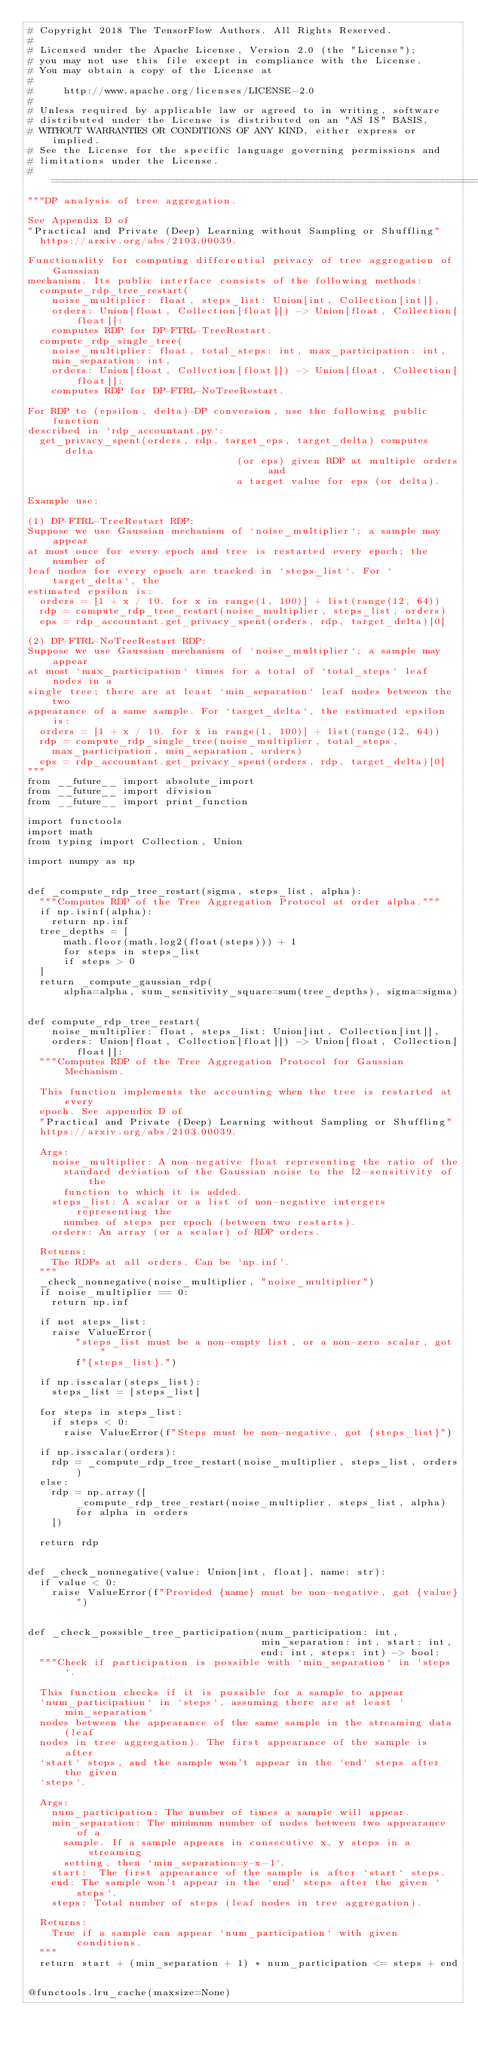<code> <loc_0><loc_0><loc_500><loc_500><_Python_># Copyright 2018 The TensorFlow Authors. All Rights Reserved.
#
# Licensed under the Apache License, Version 2.0 (the "License");
# you may not use this file except in compliance with the License.
# You may obtain a copy of the License at
#
#     http://www.apache.org/licenses/LICENSE-2.0
#
# Unless required by applicable law or agreed to in writing, software
# distributed under the License is distributed on an "AS IS" BASIS,
# WITHOUT WARRANTIES OR CONDITIONS OF ANY KIND, either express or implied.
# See the License for the specific language governing permissions and
# limitations under the License.
# ==============================================================================
"""DP analysis of tree aggregation.

See Appendix D of
"Practical and Private (Deep) Learning without Sampling or Shuffling"
  https://arxiv.org/abs/2103.00039.

Functionality for computing differential privacy of tree aggregation of Gaussian
mechanism. Its public interface consists of the following methods:
  compute_rdp_tree_restart(
    noise_multiplier: float, steps_list: Union[int, Collection[int]],
    orders: Union[float, Collection[float]]) -> Union[float, Collection[float]]:
    computes RDP for DP-FTRL-TreeRestart.
  compute_rdp_single_tree(
    noise_multiplier: float, total_steps: int, max_participation: int,
    min_separation: int,
    orders: Union[float, Collection[float]]) -> Union[float, Collection[float]]:
    computes RDP for DP-FTRL-NoTreeRestart.

For RDP to (epsilon, delta)-DP conversion, use the following public function
described in `rdp_accountant.py`:
  get_privacy_spent(orders, rdp, target_eps, target_delta) computes delta
                                   (or eps) given RDP at multiple orders and
                                   a target value for eps (or delta).

Example use:

(1) DP-FTRL-TreeRestart RDP:
Suppose we use Gaussian mechanism of `noise_multiplier`; a sample may appear
at most once for every epoch and tree is restarted every epoch; the number of
leaf nodes for every epoch are tracked in `steps_list`. For `target_delta`, the
estimated epsilon is:
  orders = [1 + x / 10. for x in range(1, 100)] + list(range(12, 64))
  rdp = compute_rdp_tree_restart(noise_multiplier, steps_list, orders)
  eps = rdp_accountant.get_privacy_spent(orders, rdp, target_delta)[0]

(2) DP-FTRL-NoTreeRestart RDP:
Suppose we use Gaussian mechanism of `noise_multiplier`; a sample may appear
at most `max_participation` times for a total of `total_steps` leaf nodes in a
single tree; there are at least `min_separation` leaf nodes between the two
appearance of a same sample. For `target_delta`, the estimated epsilon is:
  orders = [1 + x / 10. for x in range(1, 100)] + list(range(12, 64))
  rdp = compute_rdp_single_tree(noise_multiplier, total_steps,
    max_participation, min_separation, orders)
  eps = rdp_accountant.get_privacy_spent(orders, rdp, target_delta)[0]
"""
from __future__ import absolute_import
from __future__ import division
from __future__ import print_function

import functools
import math
from typing import Collection, Union

import numpy as np


def _compute_rdp_tree_restart(sigma, steps_list, alpha):
  """Computes RDP of the Tree Aggregation Protocol at order alpha."""
  if np.isinf(alpha):
    return np.inf
  tree_depths = [
      math.floor(math.log2(float(steps))) + 1
      for steps in steps_list
      if steps > 0
  ]
  return _compute_gaussian_rdp(
      alpha=alpha, sum_sensitivity_square=sum(tree_depths), sigma=sigma)


def compute_rdp_tree_restart(
    noise_multiplier: float, steps_list: Union[int, Collection[int]],
    orders: Union[float, Collection[float]]) -> Union[float, Collection[float]]:
  """Computes RDP of the Tree Aggregation Protocol for Gaussian Mechanism.

  This function implements the accounting when the tree is restarted at every
  epoch. See appendix D of
  "Practical and Private (Deep) Learning without Sampling or Shuffling"
  https://arxiv.org/abs/2103.00039.

  Args:
    noise_multiplier: A non-negative float representing the ratio of the
      standard deviation of the Gaussian noise to the l2-sensitivity of the
      function to which it is added.
    steps_list: A scalar or a list of non-negative intergers representing the
      number of steps per epoch (between two restarts).
    orders: An array (or a scalar) of RDP orders.

  Returns:
    The RDPs at all orders. Can be `np.inf`.
  """
  _check_nonnegative(noise_multiplier, "noise_multiplier")
  if noise_multiplier == 0:
    return np.inf

  if not steps_list:
    raise ValueError(
        "steps_list must be a non-empty list, or a non-zero scalar, got "
        f"{steps_list}.")

  if np.isscalar(steps_list):
    steps_list = [steps_list]

  for steps in steps_list:
    if steps < 0:
      raise ValueError(f"Steps must be non-negative, got {steps_list}")

  if np.isscalar(orders):
    rdp = _compute_rdp_tree_restart(noise_multiplier, steps_list, orders)
  else:
    rdp = np.array([
        _compute_rdp_tree_restart(noise_multiplier, steps_list, alpha)
        for alpha in orders
    ])

  return rdp


def _check_nonnegative(value: Union[int, float], name: str):
  if value < 0:
    raise ValueError(f"Provided {name} must be non-negative, got {value}")


def _check_possible_tree_participation(num_participation: int,
                                       min_separation: int, start: int,
                                       end: int, steps: int) -> bool:
  """Check if participation is possible with `min_separation` in `steps`.

  This function checks if it is possible for a sample to appear
  `num_participation` in `steps`, assuming there are at least `min_separation`
  nodes between the appearance of the same sample in the streaming data (leaf
  nodes in tree aggregation). The first appearance of the sample is after
  `start` steps, and the sample won't appear in the `end` steps after the given
  `steps`.

  Args:
    num_participation: The number of times a sample will appear.
    min_separation: The minimum number of nodes between two appearance of a
      sample. If a sample appears in consecutive x, y steps in a streaming
      setting, then `min_separation=y-x-1`.
    start:  The first appearance of the sample is after `start` steps.
    end: The sample won't appear in the `end` steps after the given `steps`.
    steps: Total number of steps (leaf nodes in tree aggregation).

  Returns:
    True if a sample can appear `num_participation` with given conditions.
  """
  return start + (min_separation + 1) * num_participation <= steps + end


@functools.lru_cache(maxsize=None)</code> 